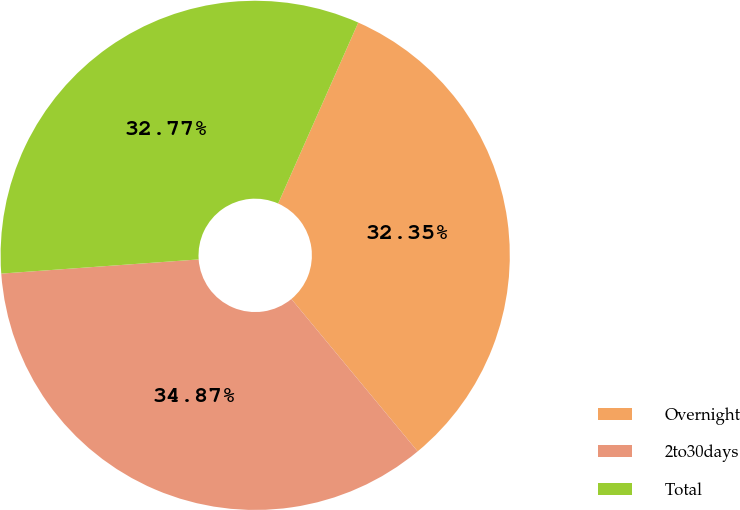<chart> <loc_0><loc_0><loc_500><loc_500><pie_chart><fcel>Overnight<fcel>2to30days<fcel>Total<nl><fcel>32.35%<fcel>34.87%<fcel>32.77%<nl></chart> 